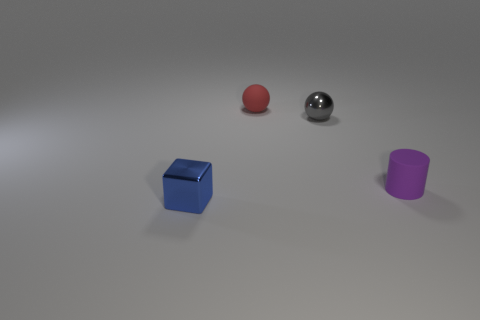Is the number of metallic balls that are behind the matte ball greater than the number of balls that are in front of the cube? Observing the image closely, it appears that there is only one metallic ball, and it is situated behind the matte red ball. None of the balls are placed in front of the cube. Thus, since there aren't any balls in front of the cube, the number of metallic balls behind the matte ball is, by default, greater. 